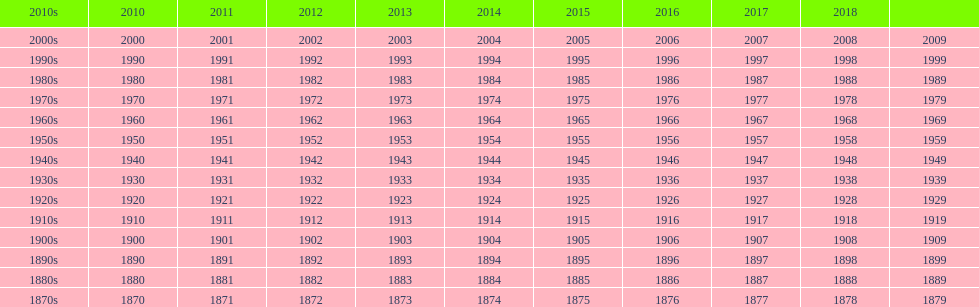In which year post-2018 is there no spot on the table? 2019. 